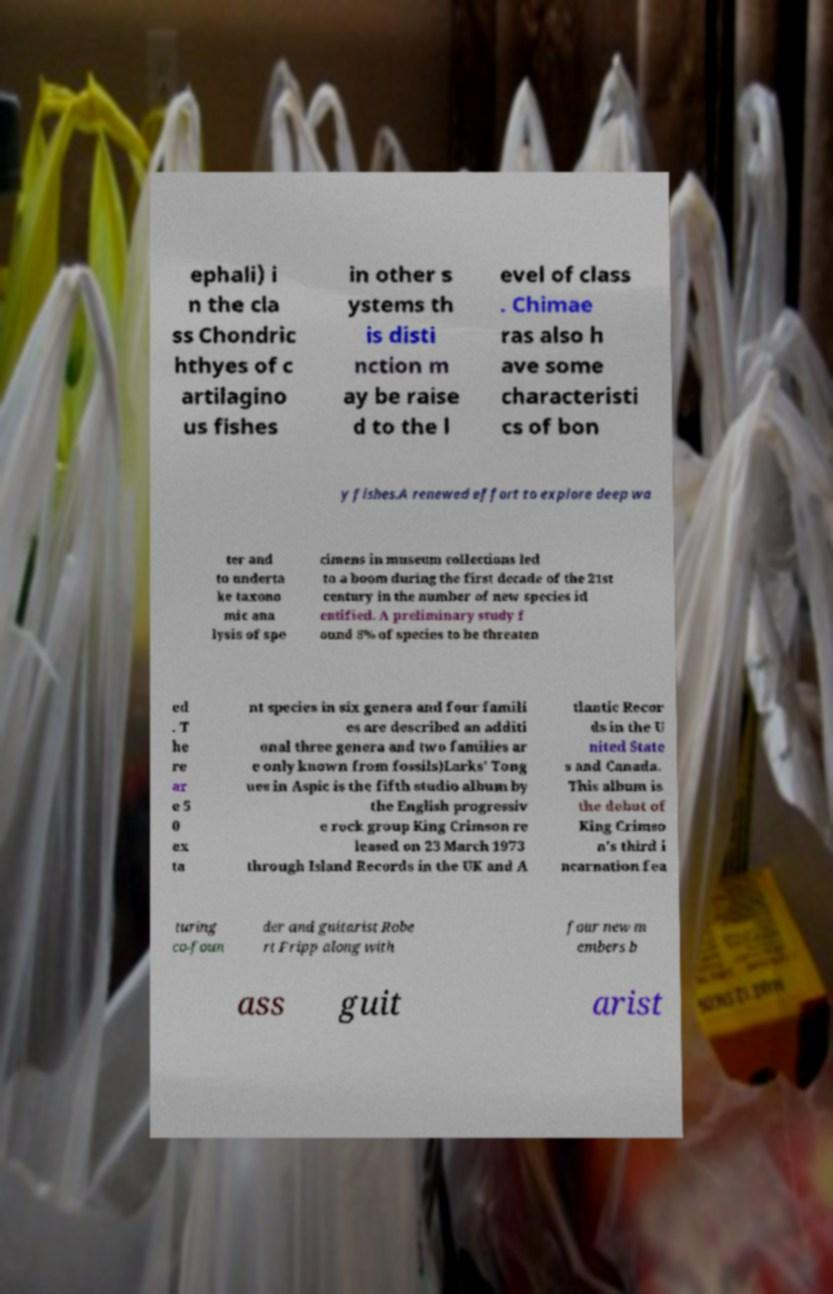Could you assist in decoding the text presented in this image and type it out clearly? ephali) i n the cla ss Chondric hthyes of c artilagino us fishes in other s ystems th is disti nction m ay be raise d to the l evel of class . Chimae ras also h ave some characteristi cs of bon y fishes.A renewed effort to explore deep wa ter and to underta ke taxono mic ana lysis of spe cimens in museum collections led to a boom during the first decade of the 21st century in the number of new species id entified. A preliminary study f ound 8% of species to be threaten ed . T he re ar e 5 0 ex ta nt species in six genera and four famili es are described an additi onal three genera and two families ar e only known from fossils)Larks' Tong ues in Aspic is the fifth studio album by the English progressiv e rock group King Crimson re leased on 23 March 1973 through Island Records in the UK and A tlantic Recor ds in the U nited State s and Canada. This album is the debut of King Crimso n's third i ncarnation fea turing co-foun der and guitarist Robe rt Fripp along with four new m embers b ass guit arist 